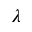Convert formula to latex. <formula><loc_0><loc_0><loc_500><loc_500>\lambda</formula> 